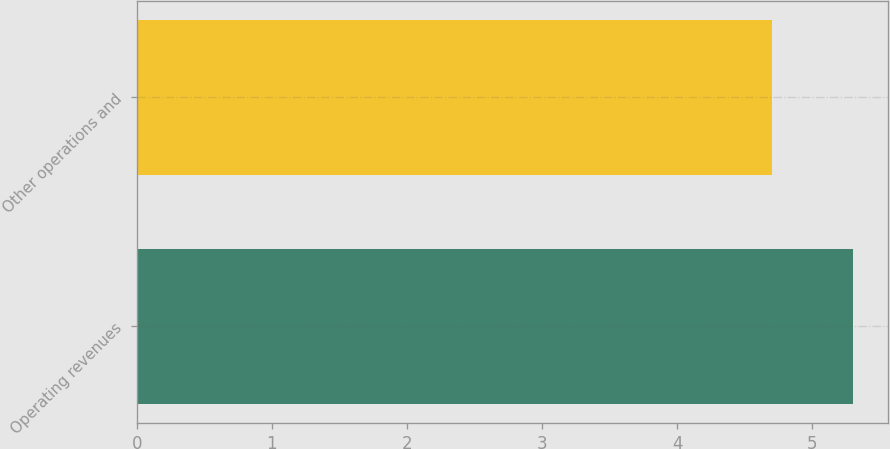Convert chart to OTSL. <chart><loc_0><loc_0><loc_500><loc_500><bar_chart><fcel>Operating revenues<fcel>Other operations and<nl><fcel>5.3<fcel>4.7<nl></chart> 